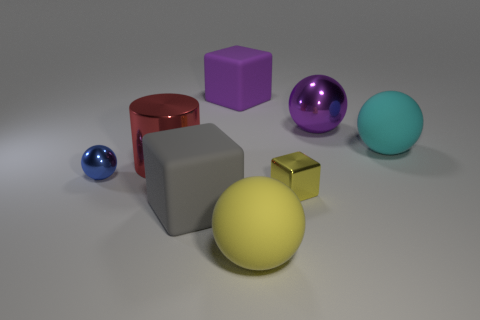What is the shape of the yellow thing that is the same material as the purple ball? The yellow object sharing the same reflective, smooth texture as the purple ball is a cube. Not only does this shape have clearly defined edges and six equal square faces, but its distinct geometry stands out amongst the various other 3D forms present in the image. 